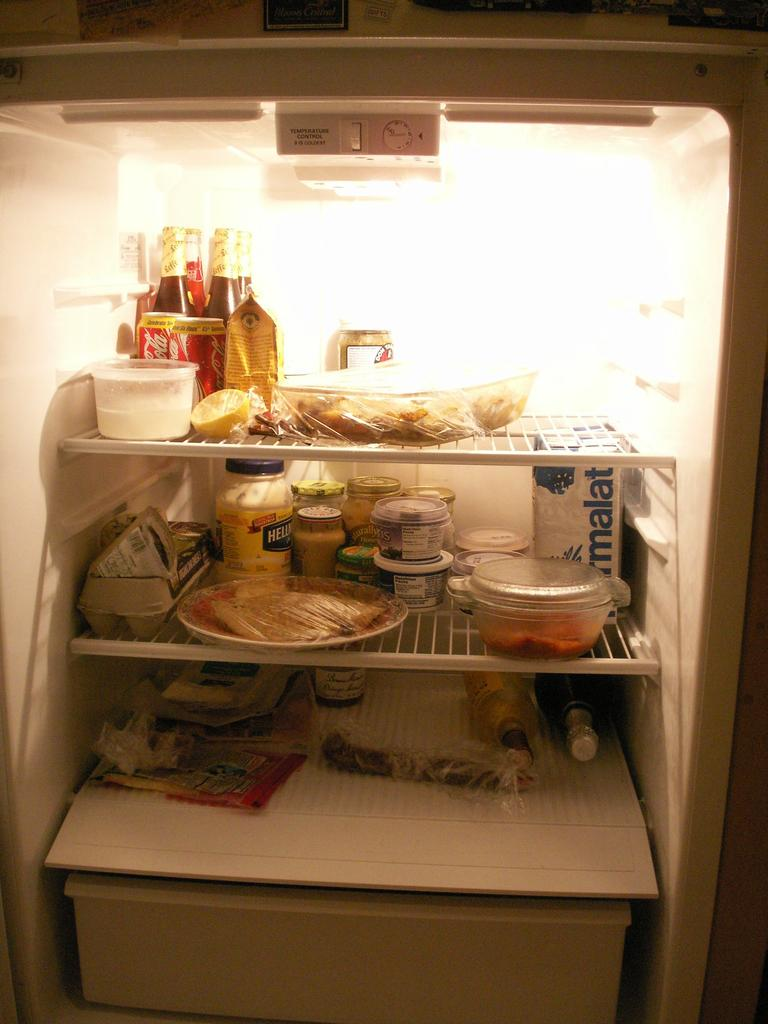Provide a one-sentence caption for the provided image. A refrigerator is full with food and drinks such as Coca-Cola and Hellman's Mayo. 